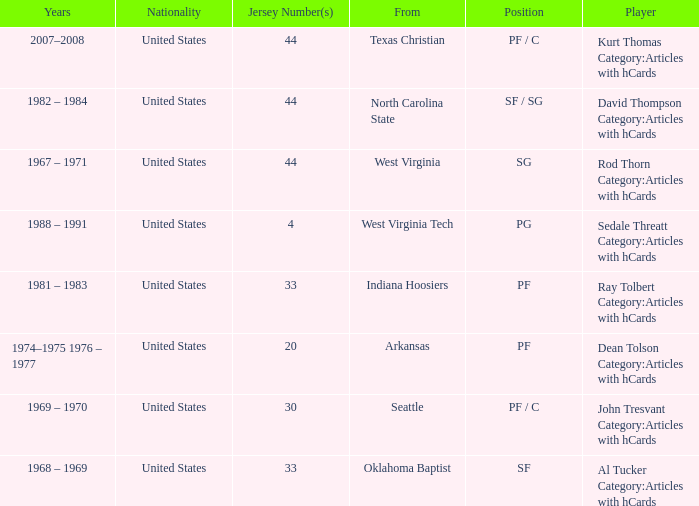What years did the player with the jersey number 33 and played position pf play? 1981 – 1983. I'm looking to parse the entire table for insights. Could you assist me with that? {'header': ['Years', 'Nationality', 'Jersey Number(s)', 'From', 'Position', 'Player'], 'rows': [['2007–2008', 'United States', '44', 'Texas Christian', 'PF / C', 'Kurt Thomas Category:Articles with hCards'], ['1982 – 1984', 'United States', '44', 'North Carolina State', 'SF / SG', 'David Thompson Category:Articles with hCards'], ['1967 – 1971', 'United States', '44', 'West Virginia', 'SG', 'Rod Thorn Category:Articles with hCards'], ['1988 – 1991', 'United States', '4', 'West Virginia Tech', 'PG', 'Sedale Threatt Category:Articles with hCards'], ['1981 – 1983', 'United States', '33', 'Indiana Hoosiers', 'PF', 'Ray Tolbert Category:Articles with hCards'], ['1974–1975 1976 – 1977', 'United States', '20', 'Arkansas', 'PF', 'Dean Tolson Category:Articles with hCards'], ['1969 – 1970', 'United States', '30', 'Seattle', 'PF / C', 'John Tresvant Category:Articles with hCards'], ['1968 – 1969', 'United States', '33', 'Oklahoma Baptist', 'SF', 'Al Tucker Category:Articles with hCards']]} 